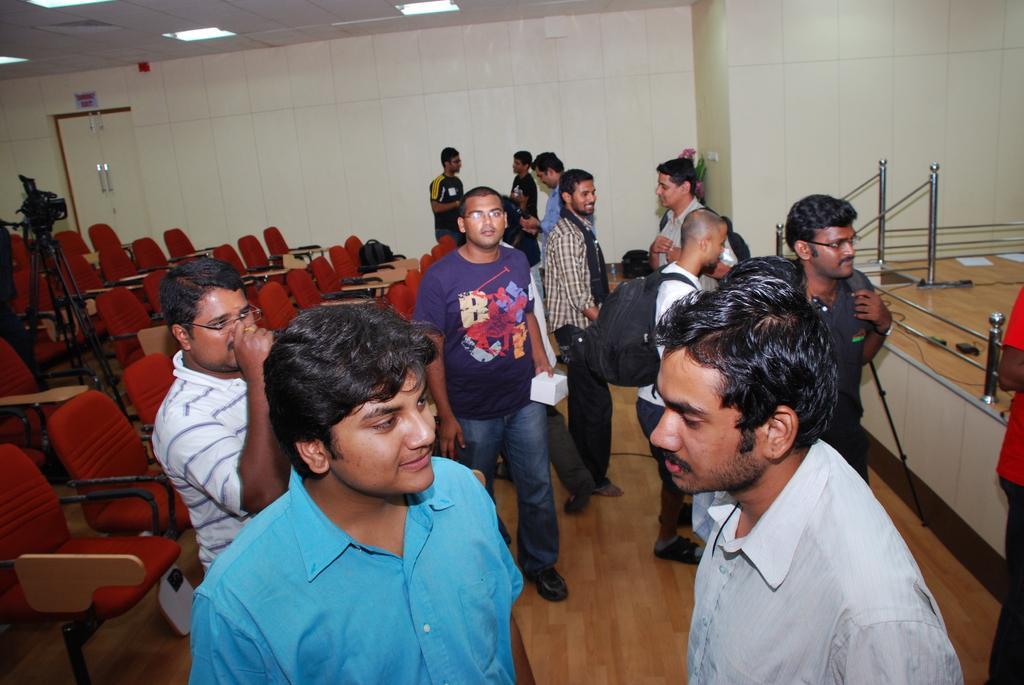Could you give a brief overview of what you see in this image? In this image there are persons standing. On the left side there are empty chairs and there is a camera on the stand and there is a door which is white in colour. On the right side there are railings and there are wires and on the top there are lights. 